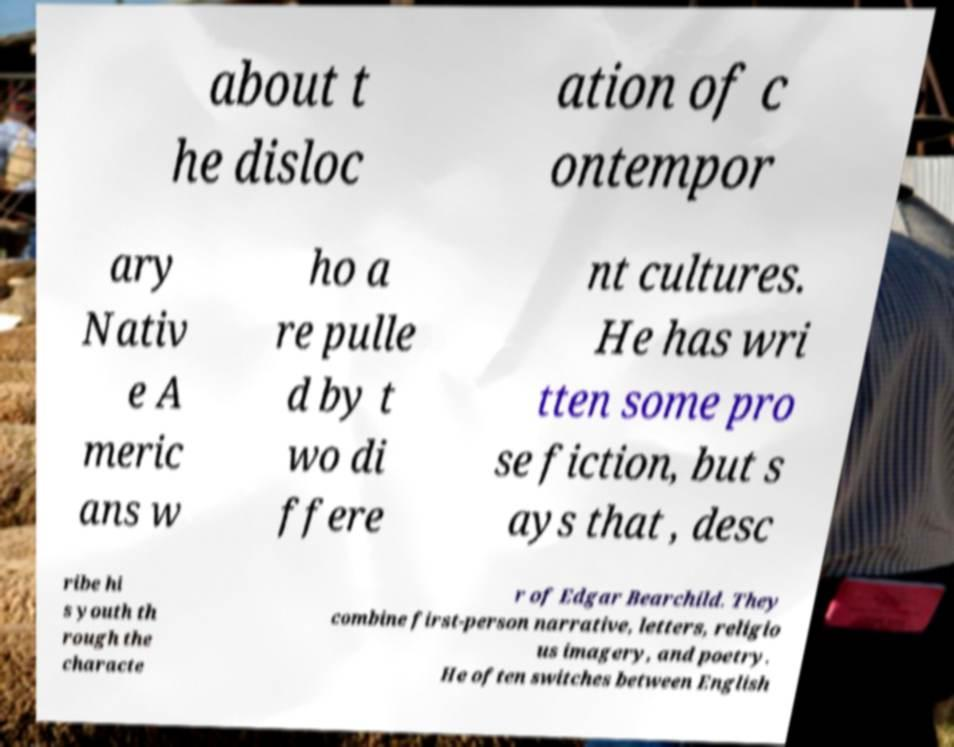Please identify and transcribe the text found in this image. about t he disloc ation of c ontempor ary Nativ e A meric ans w ho a re pulle d by t wo di ffere nt cultures. He has wri tten some pro se fiction, but s ays that , desc ribe hi s youth th rough the characte r of Edgar Bearchild. They combine first-person narrative, letters, religio us imagery, and poetry. He often switches between English 